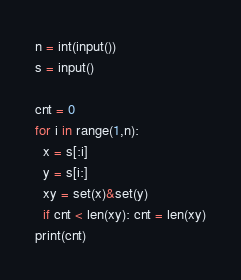Convert code to text. <code><loc_0><loc_0><loc_500><loc_500><_Python_>n = int(input())
s = input()

cnt = 0
for i in range(1,n):
  x = s[:i]
  y = s[i:]
  xy = set(x)&set(y)
  if cnt < len(xy): cnt = len(xy)
print(cnt)</code> 